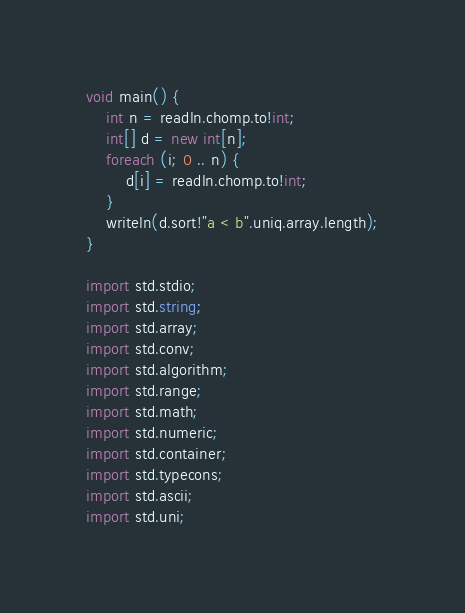Convert code to text. <code><loc_0><loc_0><loc_500><loc_500><_D_>void main() {
    int n = readln.chomp.to!int;
    int[] d = new int[n];
    foreach (i; 0 .. n) {
        d[i] = readln.chomp.to!int;
    }
    writeln(d.sort!"a < b".uniq.array.length);
}

import std.stdio;
import std.string;
import std.array;
import std.conv;
import std.algorithm;
import std.range;
import std.math;
import std.numeric;
import std.container;
import std.typecons;
import std.ascii;
import std.uni;</code> 